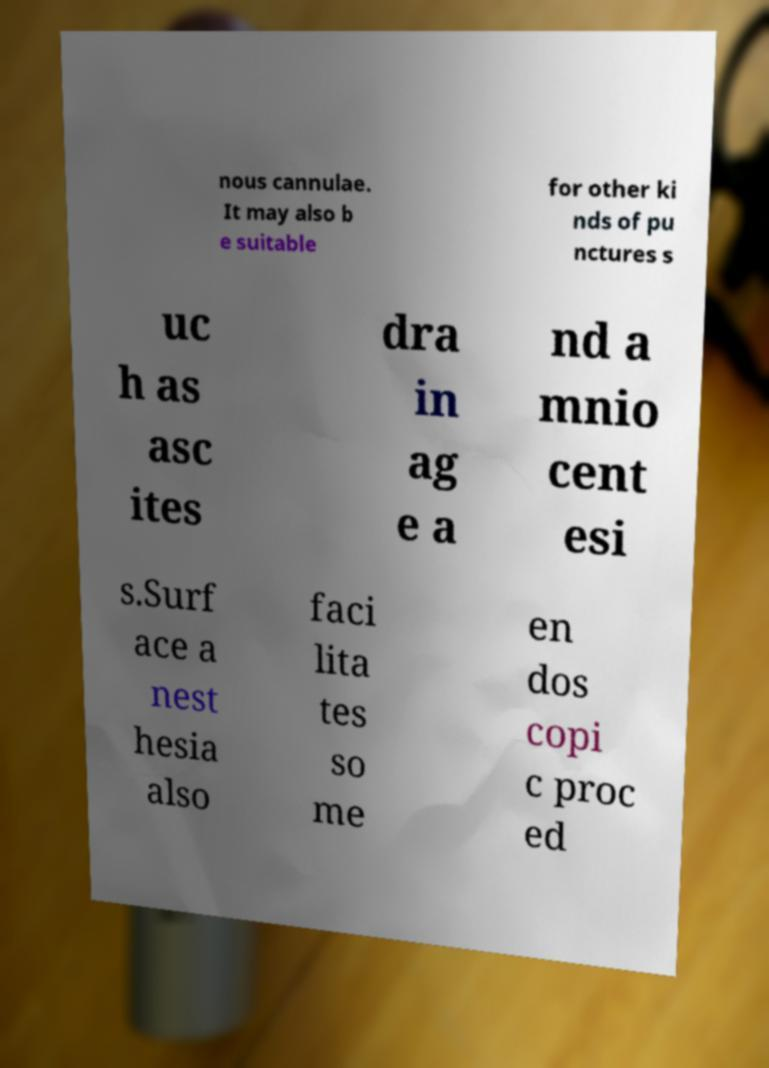Please identify and transcribe the text found in this image. nous cannulae. It may also b e suitable for other ki nds of pu nctures s uc h as asc ites dra in ag e a nd a mnio cent esi s.Surf ace a nest hesia also faci lita tes so me en dos copi c proc ed 